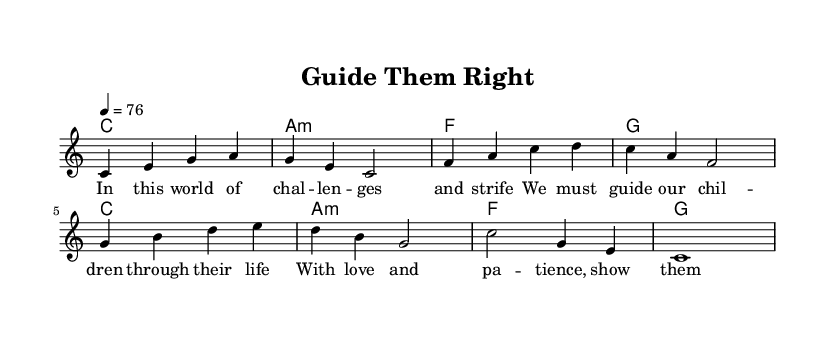What is the key signature of this music? The key signature is C major, which has no sharps or flats.
Answer: C major What is the time signature of this music? The time signature is indicated at the beginning of the score, showing how many beats are in each measure. In this case, it is 4 beats per measure.
Answer: 4/4 What is the tempo marking in this music? The tempo marking states "4 = 76," meaning there are 76 quarter note beats per minute.
Answer: 76 How many measures are there in the melody? By counting the individual measures in the melody section, there are a total of 8 measures presented.
Answer: 8 What is the primary theme of the lyrics? The lyrics talk about guiding children through challenges in life with love and patience, emphasizing strong family values.
Answer: Family values What chords are used in the harmony section? The harmony section features four chords repeated throughout: C, A minor, F, and G. These chords typically provide the harmonic structure in reggae music, supporting the melody.
Answer: C, A minor, F, G How do the lyrics reflect reggae's cultural themes? The lyrics emphasize love, patience, and guidance, which are common themes in reggae that often promote unity and support within families and communities.
Answer: Unity and support 